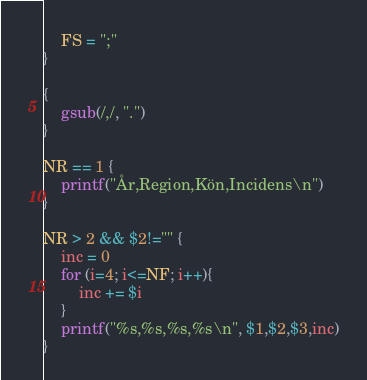Convert code to text. <code><loc_0><loc_0><loc_500><loc_500><_Awk_>	FS = ";"
}

{
	gsub(/,/, ".")
}

NR == 1 {
	printf("År,Region,Kön,Incidens\n")
}

NR > 2 && $2!="" {
	inc = 0
	for (i=4; i<=NF; i++){
		inc += $i
	}
    printf("%s,%s,%s,%s\n", $1,$2,$3,inc)
}
</code> 